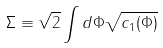Convert formula to latex. <formula><loc_0><loc_0><loc_500><loc_500>\Sigma \equiv \sqrt { 2 } \int d \Phi \sqrt { c _ { 1 } ( \Phi ) }</formula> 